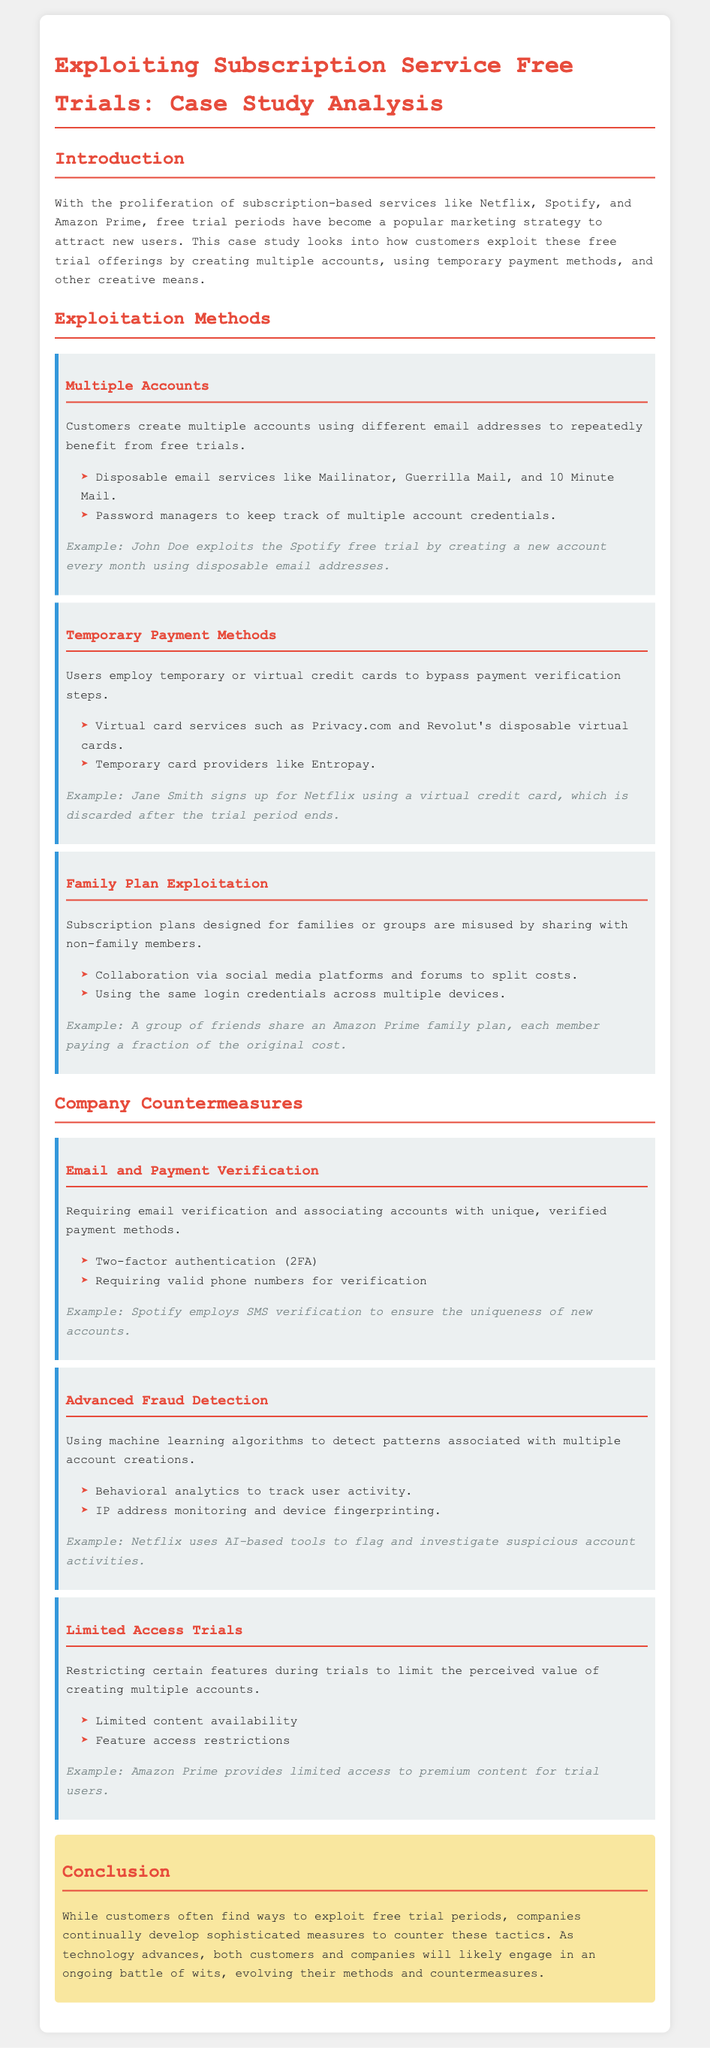what are two examples of disposable email services? The document lists Mailinator and Guerrilla Mail as examples of disposable email services.
Answer: Mailinator, Guerrilla Mail what is one temporary payment method mentioned? The document mentions virtual card services like Privacy.com as a temporary payment method.
Answer: Privacy.com how does Jane Smith exploit Netflix's free trial? Jane Smith uses a virtual credit card, which she discards after the trial period ends.
Answer: Virtual credit card what countermeasure does Spotify use for account verification? The document states that Spotify employs SMS verification to ensure the uniqueness of new accounts.
Answer: SMS verification what is one strategy used by customers to share subscription costs? The document explains that customers collaborate via social media platforms to split costs.
Answer: Social media platforms what does Netflix use to detect suspicious account activities? The document mentions that Netflix uses AI-based tools to flag and investigate suspicious account activities.
Answer: AI-based tools how many methods of exploitation are identified in the document? The document outlines three methods of exploitation related to subscription services.
Answer: Three what measure is taken to limit the perceived value of trials? The document states that limiting access to certain features during trials is one countermeasure.
Answer: Limited access to features 